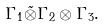Convert formula to latex. <formula><loc_0><loc_0><loc_500><loc_500>\Gamma _ { 1 } \tilde { \otimes } \Gamma _ { 2 } \otimes \Gamma _ { 3 } .</formula> 